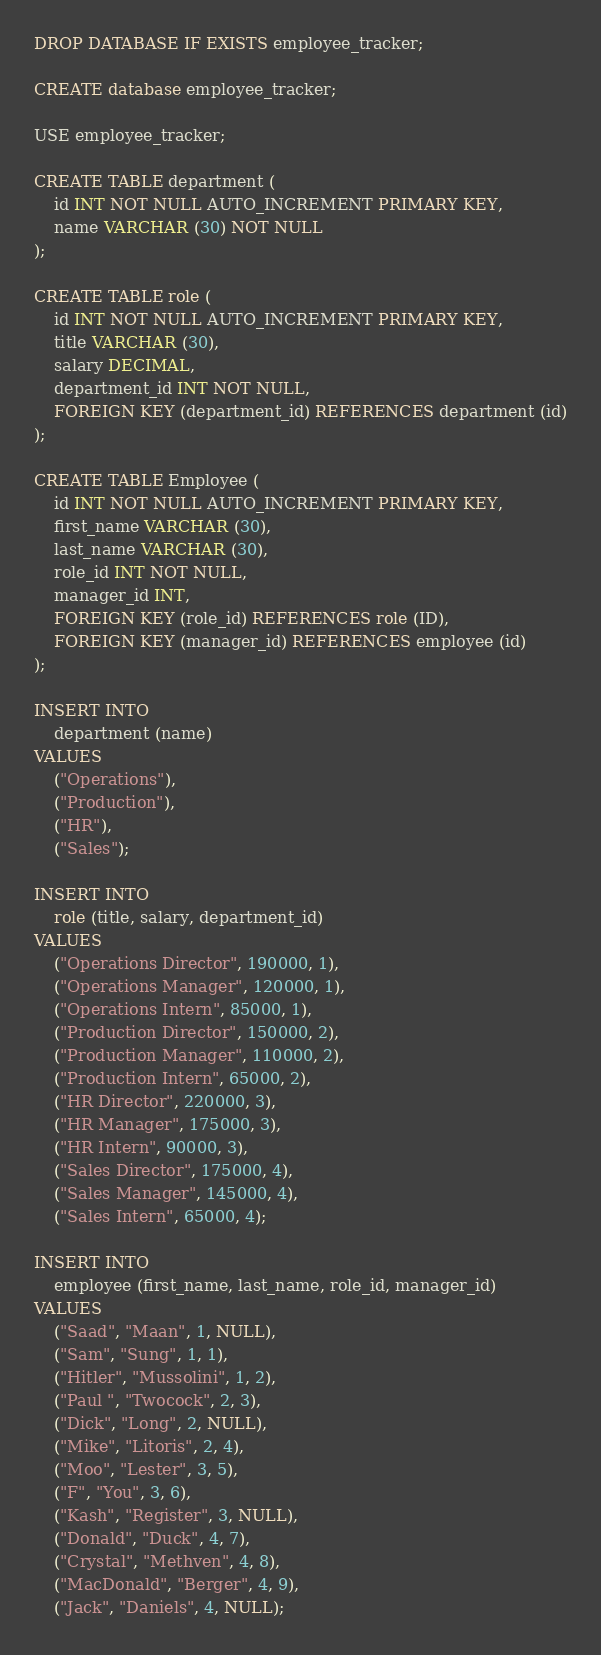Convert code to text. <code><loc_0><loc_0><loc_500><loc_500><_SQL_>DROP DATABASE IF EXISTS employee_tracker;

CREATE database employee_tracker;

USE employee_tracker;

CREATE TABLE department (
    id INT NOT NULL AUTO_INCREMENT PRIMARY KEY,
    name VARCHAR (30) NOT NULL
);

CREATE TABLE role (
    id INT NOT NULL AUTO_INCREMENT PRIMARY KEY,
    title VARCHAR (30),
    salary DECIMAL,
    department_id INT NOT NULL,
    FOREIGN KEY (department_id) REFERENCES department (id)
);

CREATE TABLE Employee (
    id INT NOT NULL AUTO_INCREMENT PRIMARY KEY,
    first_name VARCHAR (30),
    last_name VARCHAR (30),
    role_id INT NOT NULL,
    manager_id INT,
    FOREIGN KEY (role_id) REFERENCES role (ID),
    FOREIGN KEY (manager_id) REFERENCES employee (id)
);

INSERT INTO
    department (name)
VALUES
    ("Operations"),
    ("Production"),
    ("HR"),
    ("Sales");

INSERT INTO
    role (title, salary, department_id)
VALUES
    ("Operations Director", 190000, 1),
    ("Operations Manager", 120000, 1),
    ("Operations Intern", 85000, 1),
    ("Production Director", 150000, 2),
    ("Production Manager", 110000, 2),
    ("Production Intern", 65000, 2),
    ("HR Director", 220000, 3),
    ("HR Manager", 175000, 3),
    ("HR Intern", 90000, 3),
    ("Sales Director", 175000, 4),
    ("Sales Manager", 145000, 4),
    ("Sales Intern", 65000, 4);

INSERT INTO
    employee (first_name, last_name, role_id, manager_id)
VALUES
    ("Saad", "Maan", 1, NULL),
    ("Sam", "Sung", 1, 1),
    ("Hitler", "Mussolini", 1, 2),
    ("Paul ", "Twocock", 2, 3),
    ("Dick", "Long", 2, NULL),
    ("Mike", "Litoris", 2, 4),
    ("Moo", "Lester", 3, 5),
    ("F", "You", 3, 6),
    ("Kash", "Register", 3, NULL),
    ("Donald", "Duck", 4, 7),
    ("Crystal", "Methven", 4, 8),
    ("MacDonald", "Berger", 4, 9),
    ("Jack", "Daniels", 4, NULL);</code> 